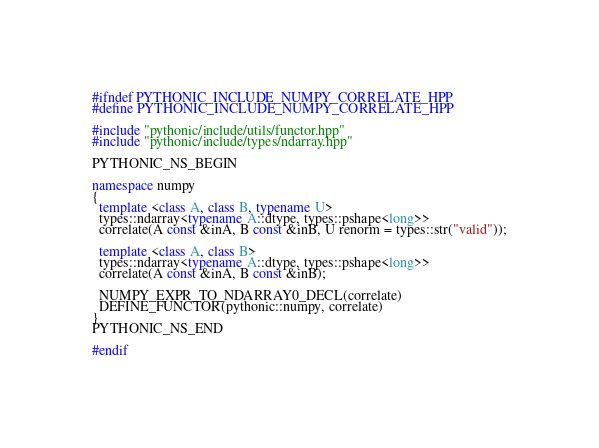<code> <loc_0><loc_0><loc_500><loc_500><_C++_>#ifndef PYTHONIC_INCLUDE_NUMPY_CORRELATE_HPP
#define PYTHONIC_INCLUDE_NUMPY_CORRELATE_HPP

#include "pythonic/include/utils/functor.hpp"
#include "pythonic/include/types/ndarray.hpp"

PYTHONIC_NS_BEGIN

namespace numpy
{
  template <class A, class B, typename U>
  types::ndarray<typename A::dtype, types::pshape<long>>
  correlate(A const &inA, B const &inB, U renorm = types::str("valid"));

  template <class A, class B>
  types::ndarray<typename A::dtype, types::pshape<long>>
  correlate(A const &inA, B const &inB);

  NUMPY_EXPR_TO_NDARRAY0_DECL(correlate)
  DEFINE_FUNCTOR(pythonic::numpy, correlate)
}
PYTHONIC_NS_END

#endif
</code> 